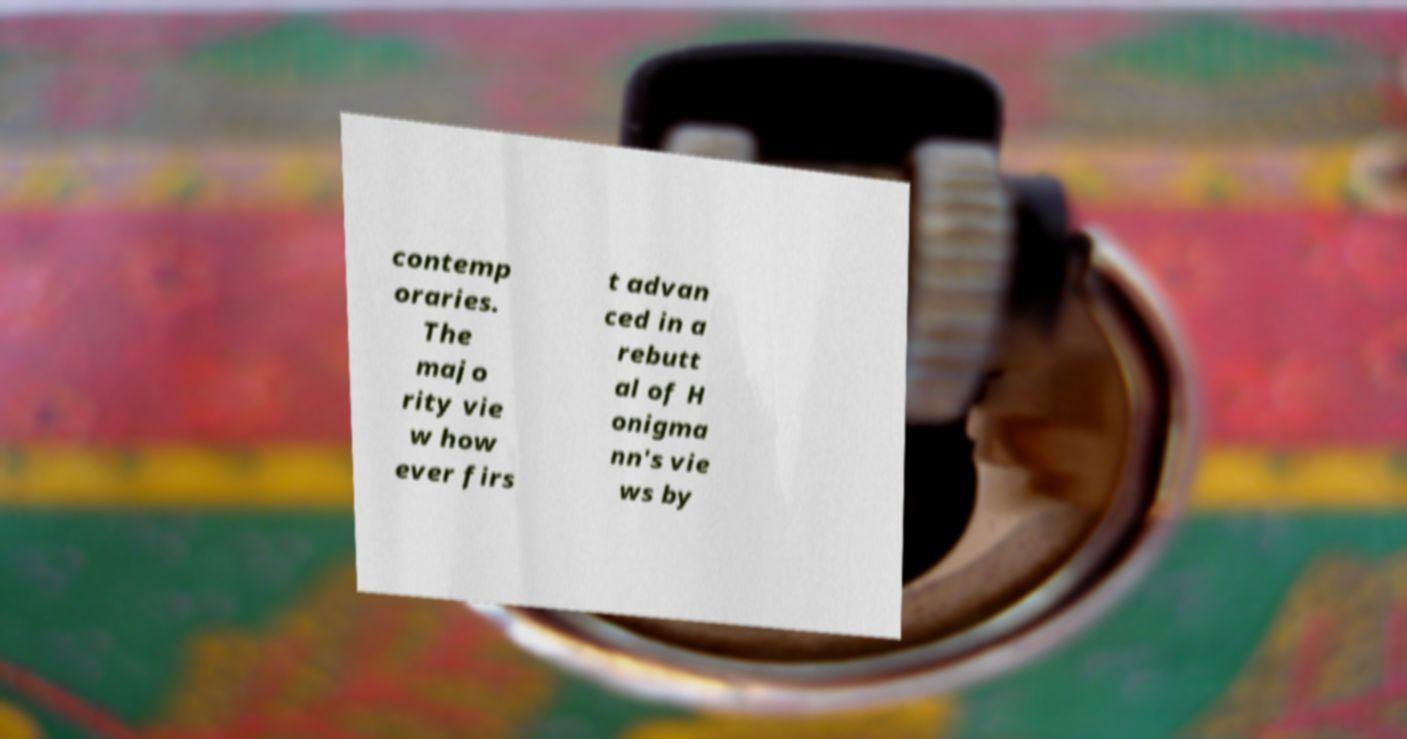For documentation purposes, I need the text within this image transcribed. Could you provide that? contemp oraries. The majo rity vie w how ever firs t advan ced in a rebutt al of H onigma nn's vie ws by 